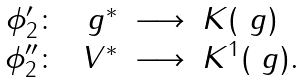Convert formula to latex. <formula><loc_0><loc_0><loc_500><loc_500>\begin{array} { r r c l } \phi _ { 2 } ^ { \prime } \colon & \ g ^ { * } & \longrightarrow & K ( \ g ) \\ \phi _ { 2 } ^ { \prime \prime } \colon & V ^ { * } & \longrightarrow & K ^ { 1 } ( \ g ) . \end{array}</formula> 